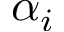Convert formula to latex. <formula><loc_0><loc_0><loc_500><loc_500>\alpha _ { i }</formula> 